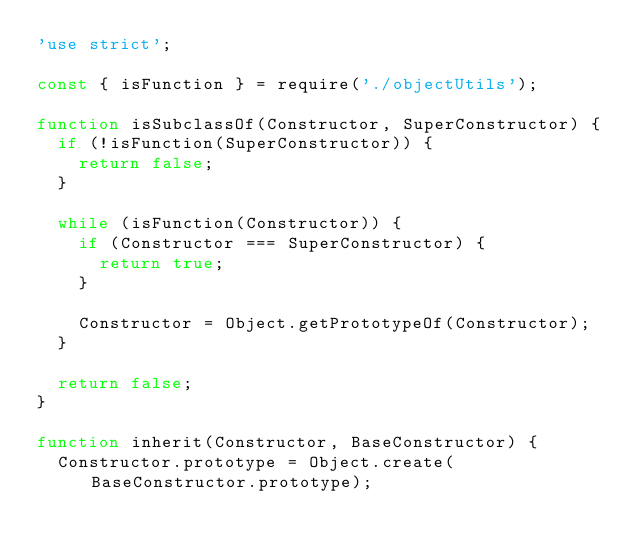Convert code to text. <code><loc_0><loc_0><loc_500><loc_500><_JavaScript_>'use strict';

const { isFunction } = require('./objectUtils');

function isSubclassOf(Constructor, SuperConstructor) {
  if (!isFunction(SuperConstructor)) {
    return false;
  }

  while (isFunction(Constructor)) {
    if (Constructor === SuperConstructor) {
      return true;
    }

    Constructor = Object.getPrototypeOf(Constructor);
  }

  return false;
}

function inherit(Constructor, BaseConstructor) {
  Constructor.prototype = Object.create(BaseConstructor.prototype);</code> 